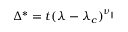<formula> <loc_0><loc_0><loc_500><loc_500>\Delta ^ { * } = t ( \lambda - \lambda _ { c } ) ^ { \nu _ { | | } }</formula> 